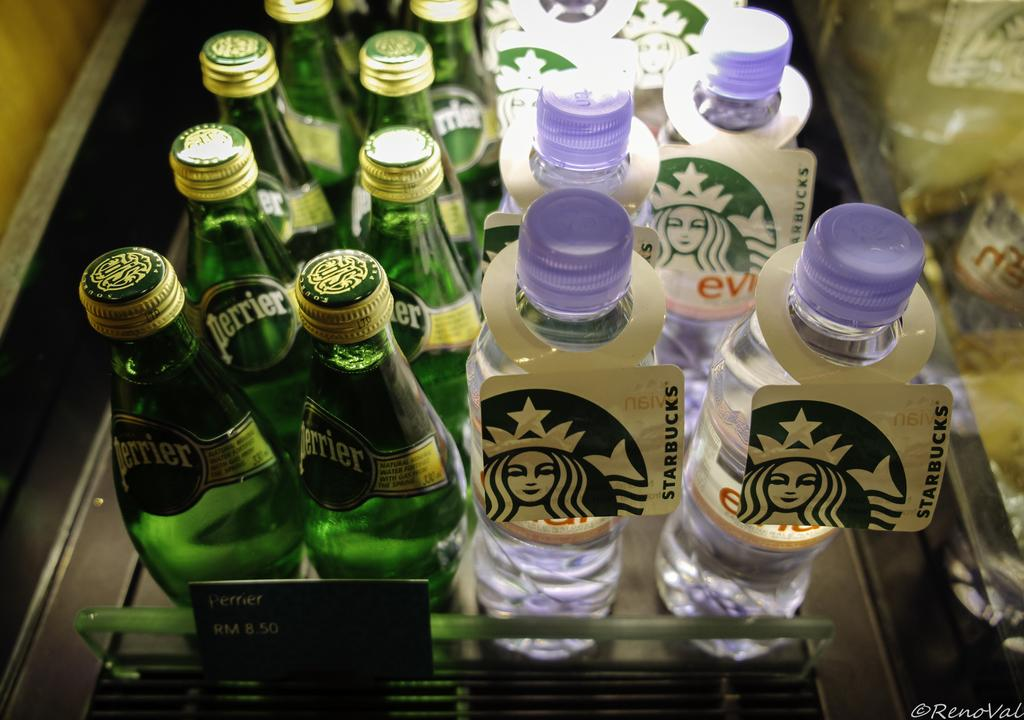What color are the bottles in the image? The bottles in the image are green. Where are the green color bottles located in the image? The green color bottles are on the left side of the image. What type of bottles are present in the image? There are water bottles in the image. Where are the water bottles located in the image? The water bottles are on the right side of the image. How are the bottles arranged in the image? The bottles are placed on a rack. What type of pizzas are being served on the tray in the image? There is no tray or pizzas present in the image; it features green color bottles and water bottles placed on a rack. 